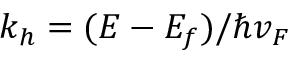Convert formula to latex. <formula><loc_0><loc_0><loc_500><loc_500>k _ { h } = ( E - E _ { f } ) / \hbar { v } _ { F }</formula> 